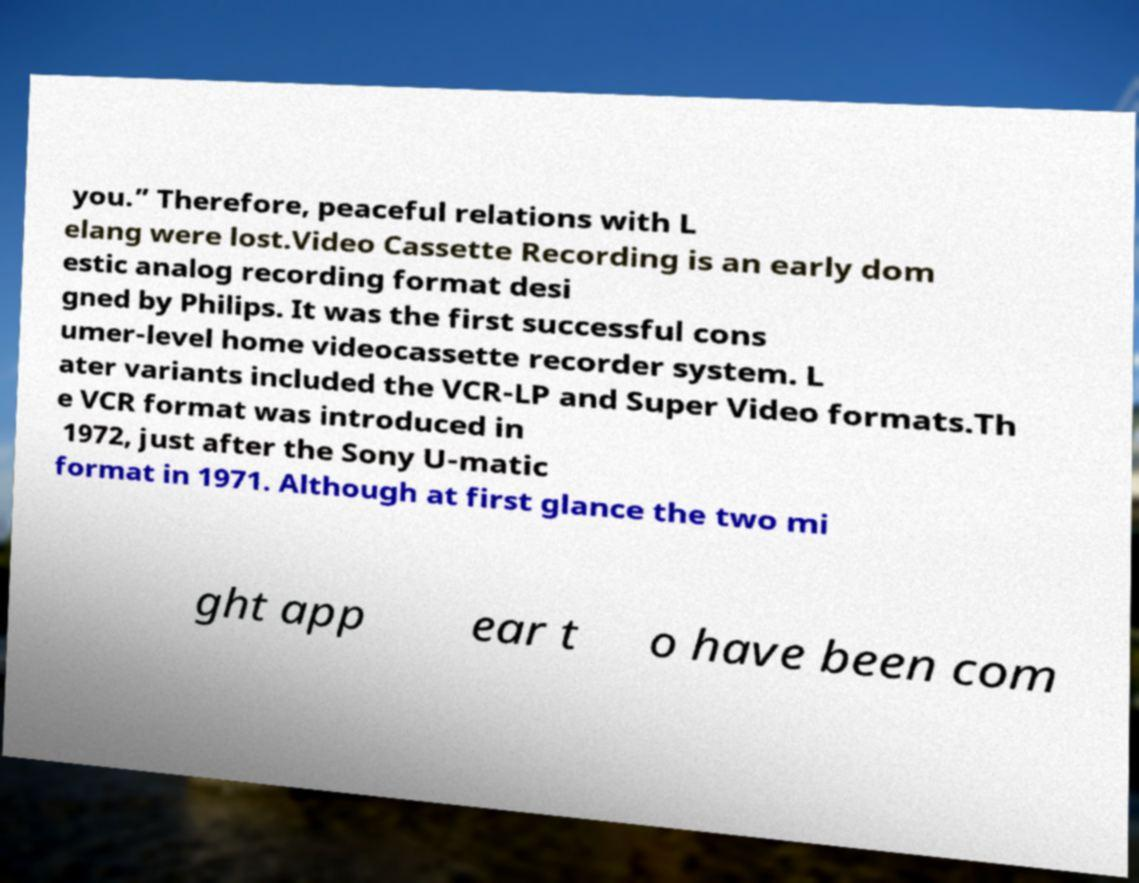Can you read and provide the text displayed in the image?This photo seems to have some interesting text. Can you extract and type it out for me? you.” Therefore, peaceful relations with L elang were lost.Video Cassette Recording is an early dom estic analog recording format desi gned by Philips. It was the first successful cons umer-level home videocassette recorder system. L ater variants included the VCR-LP and Super Video formats.Th e VCR format was introduced in 1972, just after the Sony U-matic format in 1971. Although at first glance the two mi ght app ear t o have been com 